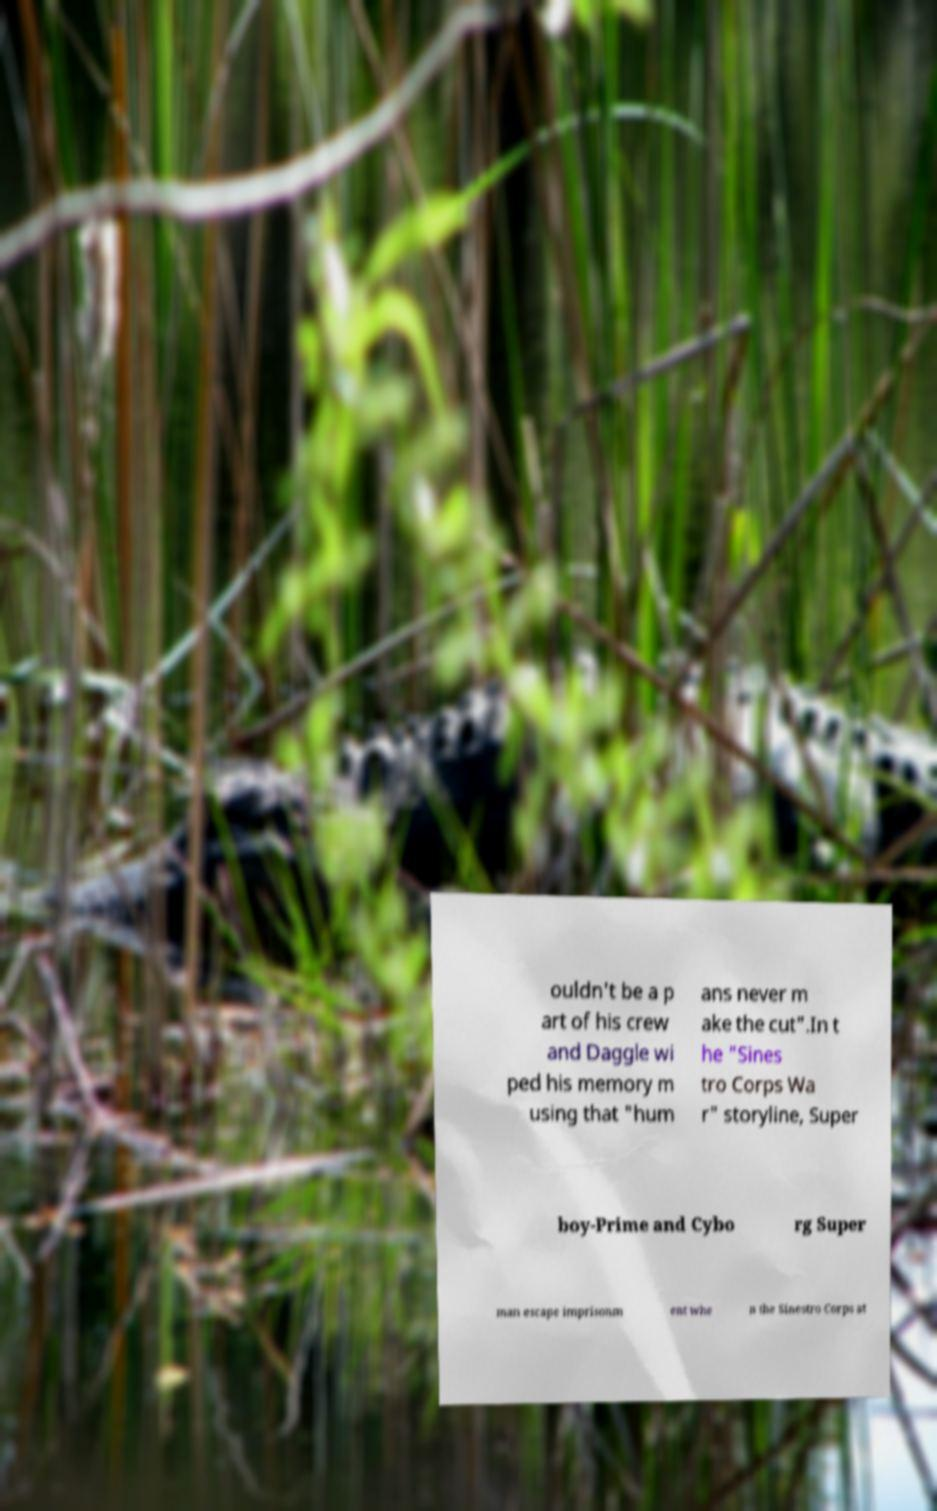Could you assist in decoding the text presented in this image and type it out clearly? ouldn't be a p art of his crew and Daggle wi ped his memory m using that "hum ans never m ake the cut".In t he "Sines tro Corps Wa r" storyline, Super boy-Prime and Cybo rg Super man escape imprisonm ent whe n the Sinestro Corps at 